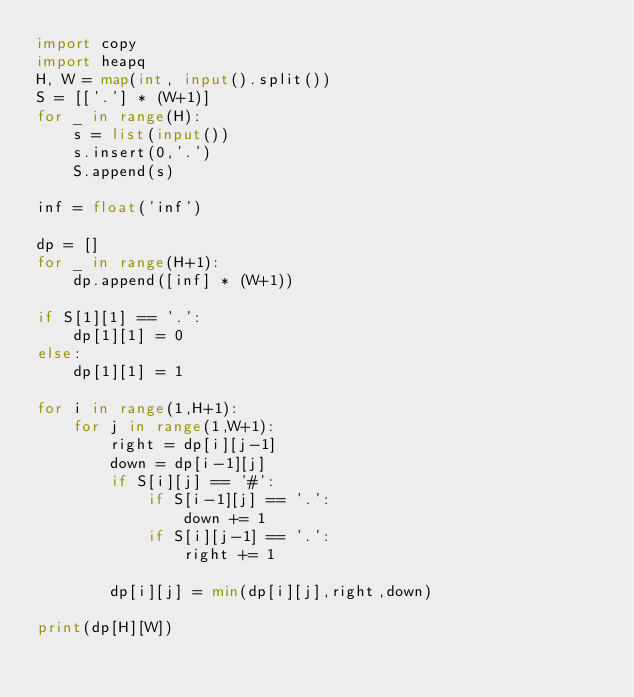<code> <loc_0><loc_0><loc_500><loc_500><_Python_>import copy
import heapq
H, W = map(int, input().split())
S = [['.'] * (W+1)]
for _ in range(H):
    s = list(input())
    s.insert(0,'.')
    S.append(s)

inf = float('inf')

dp = []
for _ in range(H+1):
    dp.append([inf] * (W+1))

if S[1][1] == '.':
    dp[1][1] = 0
else:
    dp[1][1] = 1

for i in range(1,H+1):
    for j in range(1,W+1):
        right = dp[i][j-1]
        down = dp[i-1][j]
        if S[i][j] == '#':
            if S[i-1][j] == '.':
                down += 1
            if S[i][j-1] == '.':
                right += 1

        dp[i][j] = min(dp[i][j],right,down)

print(dp[H][W])</code> 